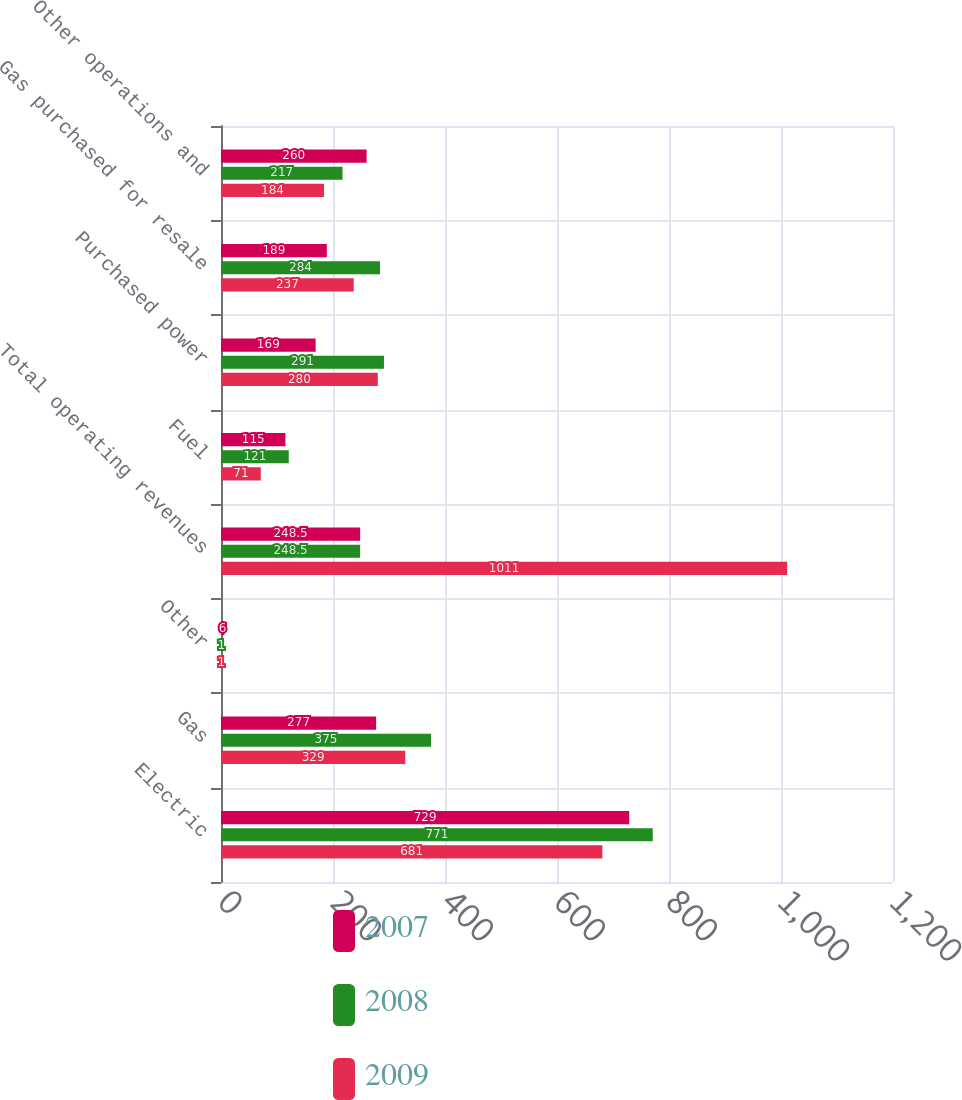<chart> <loc_0><loc_0><loc_500><loc_500><stacked_bar_chart><ecel><fcel>Electric<fcel>Gas<fcel>Other<fcel>Total operating revenues<fcel>Fuel<fcel>Purchased power<fcel>Gas purchased for resale<fcel>Other operations and<nl><fcel>2007<fcel>729<fcel>277<fcel>6<fcel>248.5<fcel>115<fcel>169<fcel>189<fcel>260<nl><fcel>2008<fcel>771<fcel>375<fcel>1<fcel>248.5<fcel>121<fcel>291<fcel>284<fcel>217<nl><fcel>2009<fcel>681<fcel>329<fcel>1<fcel>1011<fcel>71<fcel>280<fcel>237<fcel>184<nl></chart> 